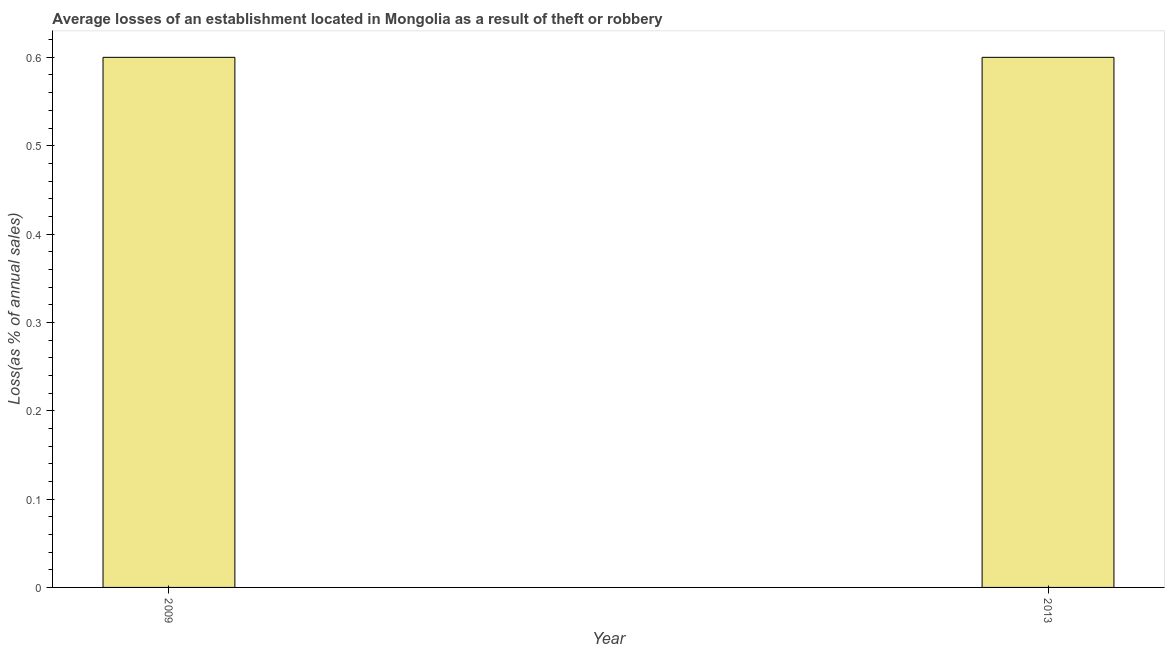Does the graph contain any zero values?
Offer a terse response. No. Does the graph contain grids?
Your answer should be very brief. No. What is the title of the graph?
Provide a succinct answer. Average losses of an establishment located in Mongolia as a result of theft or robbery. What is the label or title of the X-axis?
Give a very brief answer. Year. What is the label or title of the Y-axis?
Ensure brevity in your answer.  Loss(as % of annual sales). Across all years, what is the maximum losses due to theft?
Keep it short and to the point. 0.6. In which year was the losses due to theft minimum?
Provide a short and direct response. 2009. What is the sum of the losses due to theft?
Make the answer very short. 1.2. What is the difference between the losses due to theft in 2009 and 2013?
Ensure brevity in your answer.  0. What is the average losses due to theft per year?
Give a very brief answer. 0.6. In how many years, is the losses due to theft greater than 0.18 %?
Your response must be concise. 2. What is the ratio of the losses due to theft in 2009 to that in 2013?
Ensure brevity in your answer.  1. In how many years, is the losses due to theft greater than the average losses due to theft taken over all years?
Your answer should be very brief. 0. Are all the bars in the graph horizontal?
Offer a very short reply. No. What is the Loss(as % of annual sales) in 2013?
Your response must be concise. 0.6. What is the difference between the Loss(as % of annual sales) in 2009 and 2013?
Offer a very short reply. 0. What is the ratio of the Loss(as % of annual sales) in 2009 to that in 2013?
Make the answer very short. 1. 